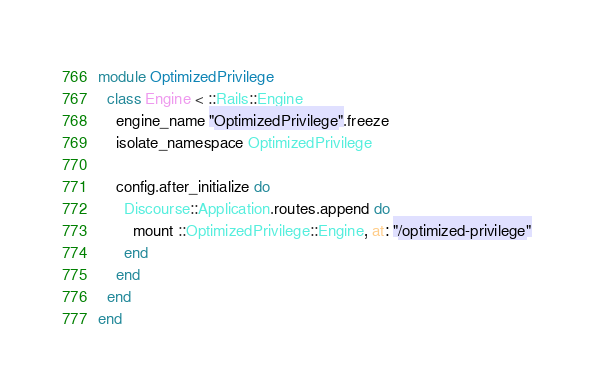<code> <loc_0><loc_0><loc_500><loc_500><_Ruby_>module OptimizedPrivilege
  class Engine < ::Rails::Engine
    engine_name "OptimizedPrivilege".freeze
    isolate_namespace OptimizedPrivilege

    config.after_initialize do
      Discourse::Application.routes.append do
        mount ::OptimizedPrivilege::Engine, at: "/optimized-privilege"
      end
    end
  end
end
</code> 